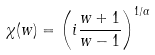Convert formula to latex. <formula><loc_0><loc_0><loc_500><loc_500>\chi ( w ) = \left ( i \frac { w + 1 } { w - 1 } \right ) ^ { 1 / \alpha }</formula> 